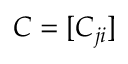<formula> <loc_0><loc_0><loc_500><loc_500>C = [ C _ { j i } ]</formula> 